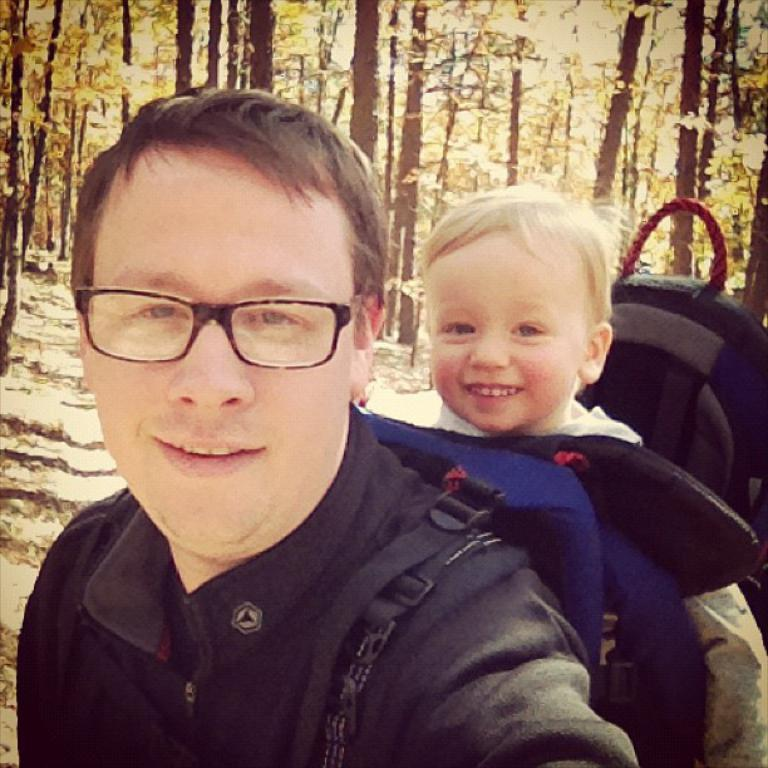Who is the main subject in the foreground of the image? There is a man in the foreground of the image. What is the man holding in the image? The man is holding a baby. What else is the man carrying in the image? The man is carrying a bag. What can be seen in the background of the image? There are trees in the background of the image. What type of fork can be seen in the man's hand in the image? There is no fork present in the man's hand or in the image. 